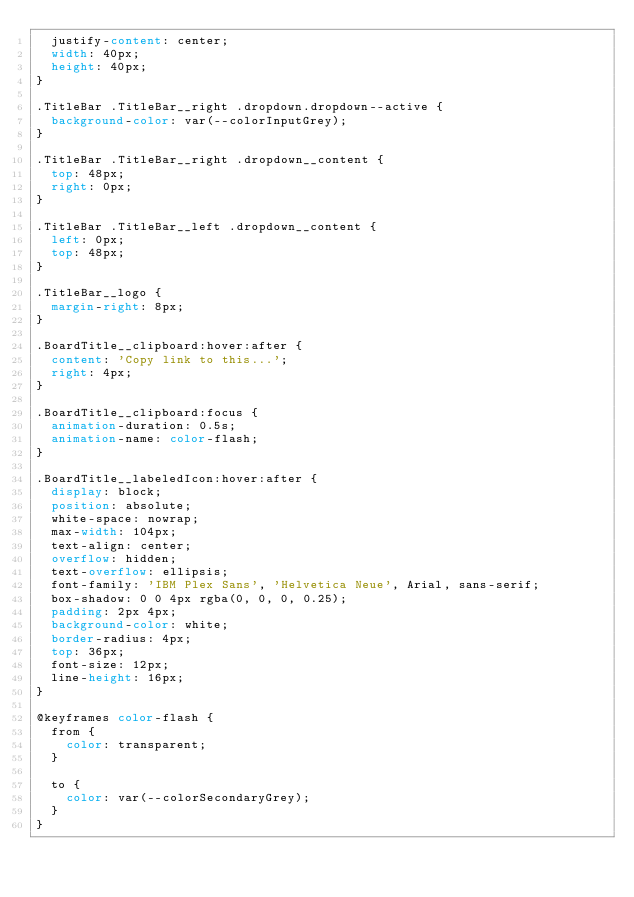<code> <loc_0><loc_0><loc_500><loc_500><_CSS_>  justify-content: center;
  width: 40px;
  height: 40px;
}

.TitleBar .TitleBar__right .dropdown.dropdown--active {
  background-color: var(--colorInputGrey);
}

.TitleBar .TitleBar__right .dropdown__content {
  top: 48px;
  right: 0px;
}

.TitleBar .TitleBar__left .dropdown__content {
  left: 0px;
  top: 48px;
}

.TitleBar__logo {
  margin-right: 8px;
}

.BoardTitle__clipboard:hover:after {
  content: 'Copy link to this...';
  right: 4px;
}

.BoardTitle__clipboard:focus {
  animation-duration: 0.5s;
  animation-name: color-flash;
}

.BoardTitle__labeledIcon:hover:after {
  display: block;
  position: absolute;
  white-space: nowrap;
  max-width: 104px;
  text-align: center;
  overflow: hidden;
  text-overflow: ellipsis;
  font-family: 'IBM Plex Sans', 'Helvetica Neue', Arial, sans-serif;
  box-shadow: 0 0 4px rgba(0, 0, 0, 0.25);
  padding: 2px 4px;
  background-color: white;
  border-radius: 4px;
  top: 36px;
  font-size: 12px;
  line-height: 16px;
}

@keyframes color-flash {
  from {
    color: transparent;
  }

  to {
    color: var(--colorSecondaryGrey);
  }
}
</code> 